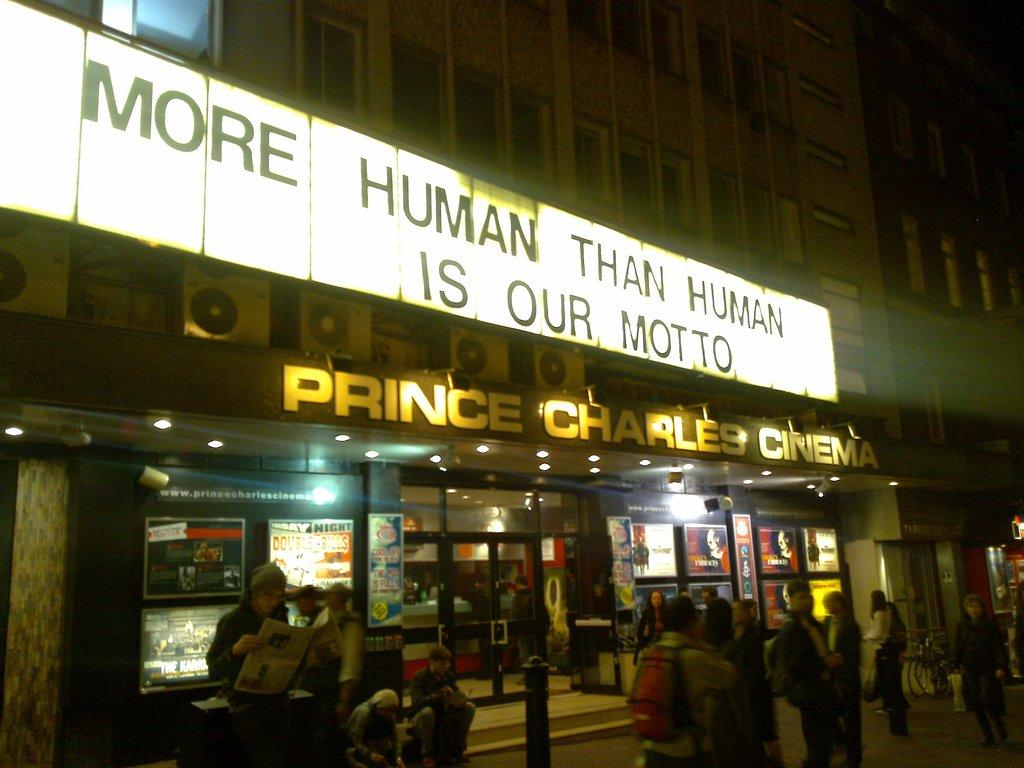<image>
Relay a brief, clear account of the picture shown. A cinema that believes in becoming more human than human. 